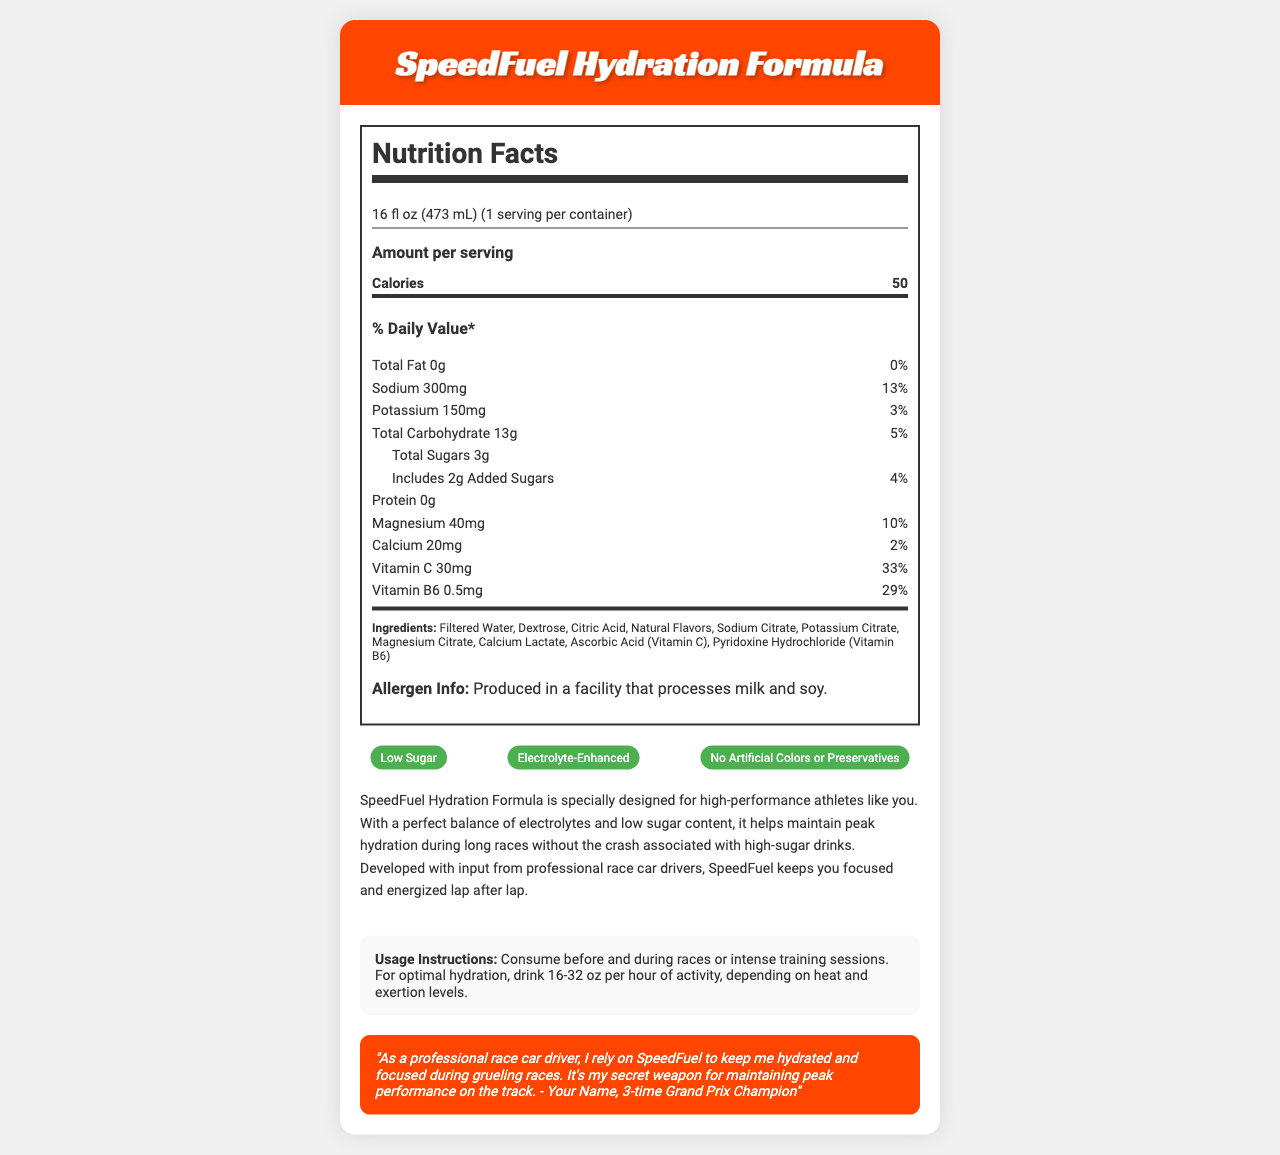what is the product name? The product name is clearly labeled at the top of the document.
Answer: SpeedFuel Hydration Formula how many calories are in one serving? The nutrition label shows that there are 50 calories per serving.
Answer: 50 what is the amount of sodium per serving? The label lists 300mg of sodium as the amount per serving.
Answer: 300mg how much vitamin C is in one serving? According to the nutrition facts, one serving contains 30mg of Vitamin C.
Answer: 30mg what is the daily value percentage of total fat? The label shows 0g of total fat with a 0% daily value percentage.
Answer: 0% what are the total sugars per serving? A. 0g B. 3g C. 5g The document lists total sugars as 3g per serving.
Answer: B what is the serving size? A. 12 fl oz B. 16 fl oz C. 20 fl oz The serving size is specified as 16 fl oz (473 mL).
Answer: B how many servings are there per container? The document indicates one serving per container.
Answer: 1 how much potassium does one serving provide? The nutrition label shows 150mg of potassium per serving.
Answer: 150mg does the product have any protein? The document lists 0g of protein.
Answer: No what vitamins are included in the drink? The nutrition facts specify the presence of Vitamin C and Vitamin B6.
Answer: Vitamin C, Vitamin B6 is the product low in sugar? The document claims that the product is low in sugar.
Answer: Yes what are the usage instructions for the drink? The usage instructions specify consumption before and during races or training sessions, with recommended intake based on activity level.
Answer: Consume before and during races or intense training sessions. For optimal hydration, drink 16-32 oz per hour of activity, depending on heat and exertion levels. what claim is NOT made about the product? A. Low Sugar B. Organic Ingredients C. Electrolyte-Enhanced The claims listed include Low Sugar and Electrolyte-Enhanced, but not Organic Ingredients.
Answer: B how much magnesium is included in one serving? The document lists 40mg of magnesium per serving.
Answer: 40mg describe the overall purpose and main idea of this document. This summary encapsulates the primary information and purpose presented in the document.
Answer: The document is a detailed nutrition label and description for the SpeedFuel Hydration Formula, a sports drink designed for high-performance athletes, especially race car drivers. It highlights its low-sugar content, electrolyte-enhancement, and usage instructions for maintaining hydration during races. who gave the endorsement for the product? The endorsement is attributed to "Your Name, 3-time Grand Prix Champion."
Answer: Your Name, 3-time Grand Prix Champion how many ingredients are in the product? The exact number of ingredients is not provided explicitly; we only see the listed ingredients.
Answer: Cannot be determined is there any information about allergens in the product? The allergen information states that the product is produced in a facility that processes milk and soy.
Answer: Yes 